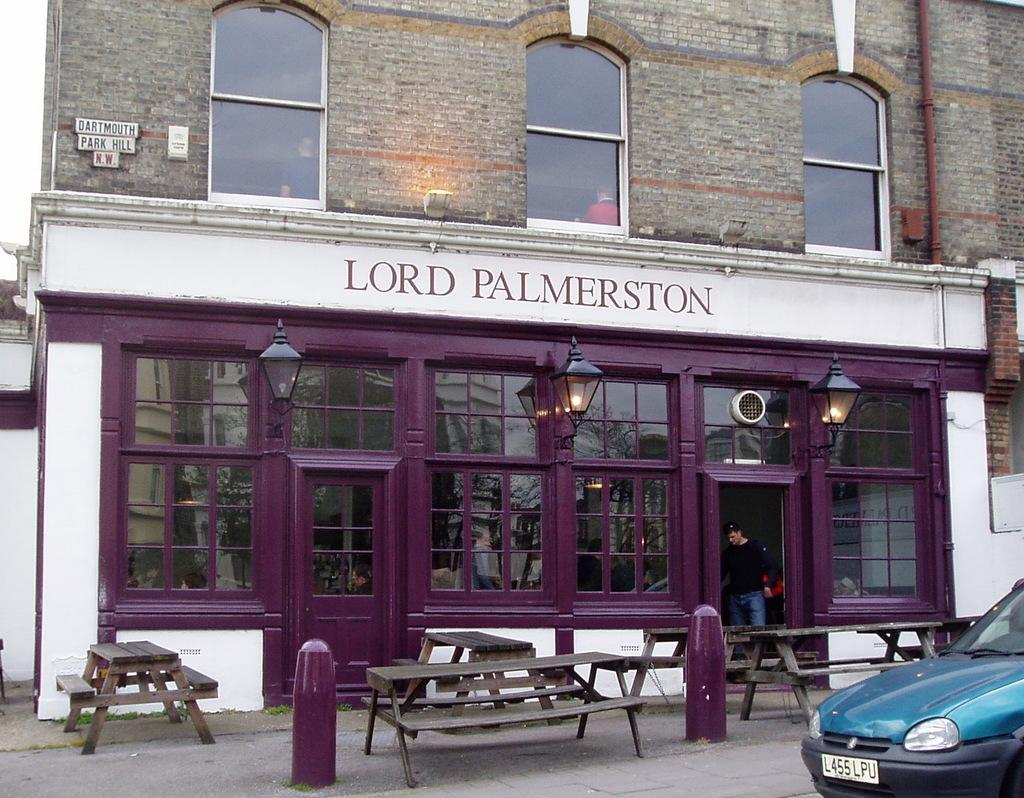Who or what is present in the image? There is a person in the image. What type of vehicle is visible in the image? There is a car in the image. What type of seating is available in the image? There are benches in the image. What type of illumination is present in the image? There are lights in the image. What type of structure is visible in the image? There is a building in the image. Can you hear the waves crashing in the image? There are no waves present in the image, so it is not possible to hear them. What type of cart is visible in the image? There is no cart present in the image. 